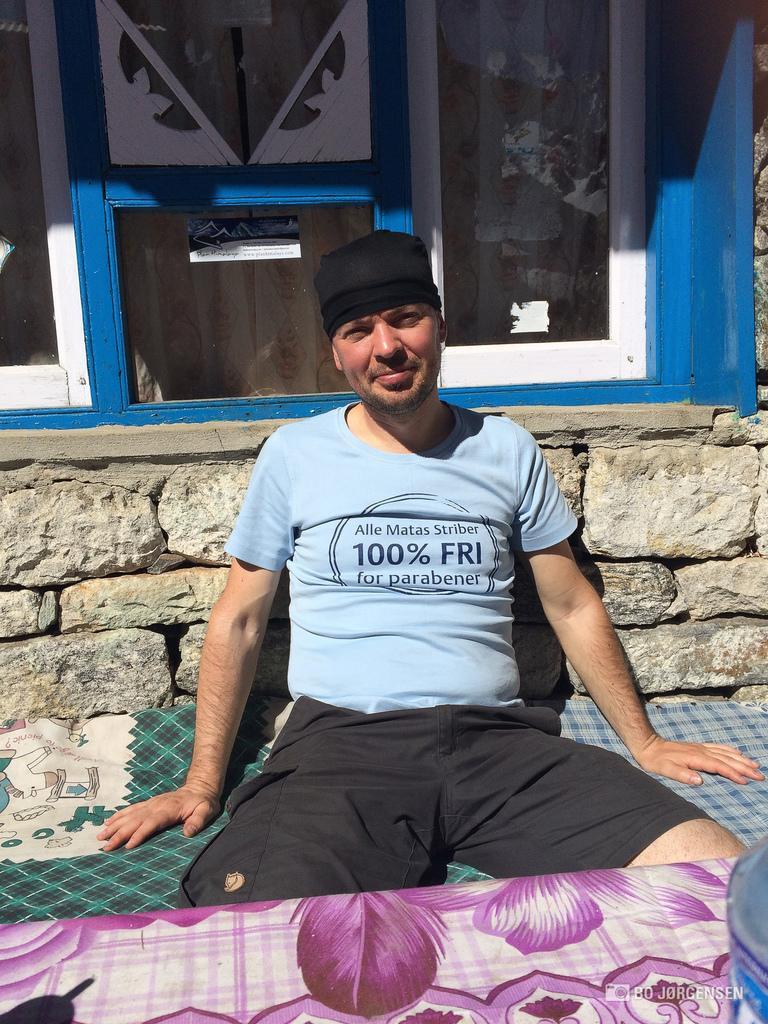Please provide a concise description of this image. In this picture we can see a man is sitting and smiling, in the background there is a glass window, from the glass we can see a curtain, there are some stones in the middle, at the bottom there is a cloth. 